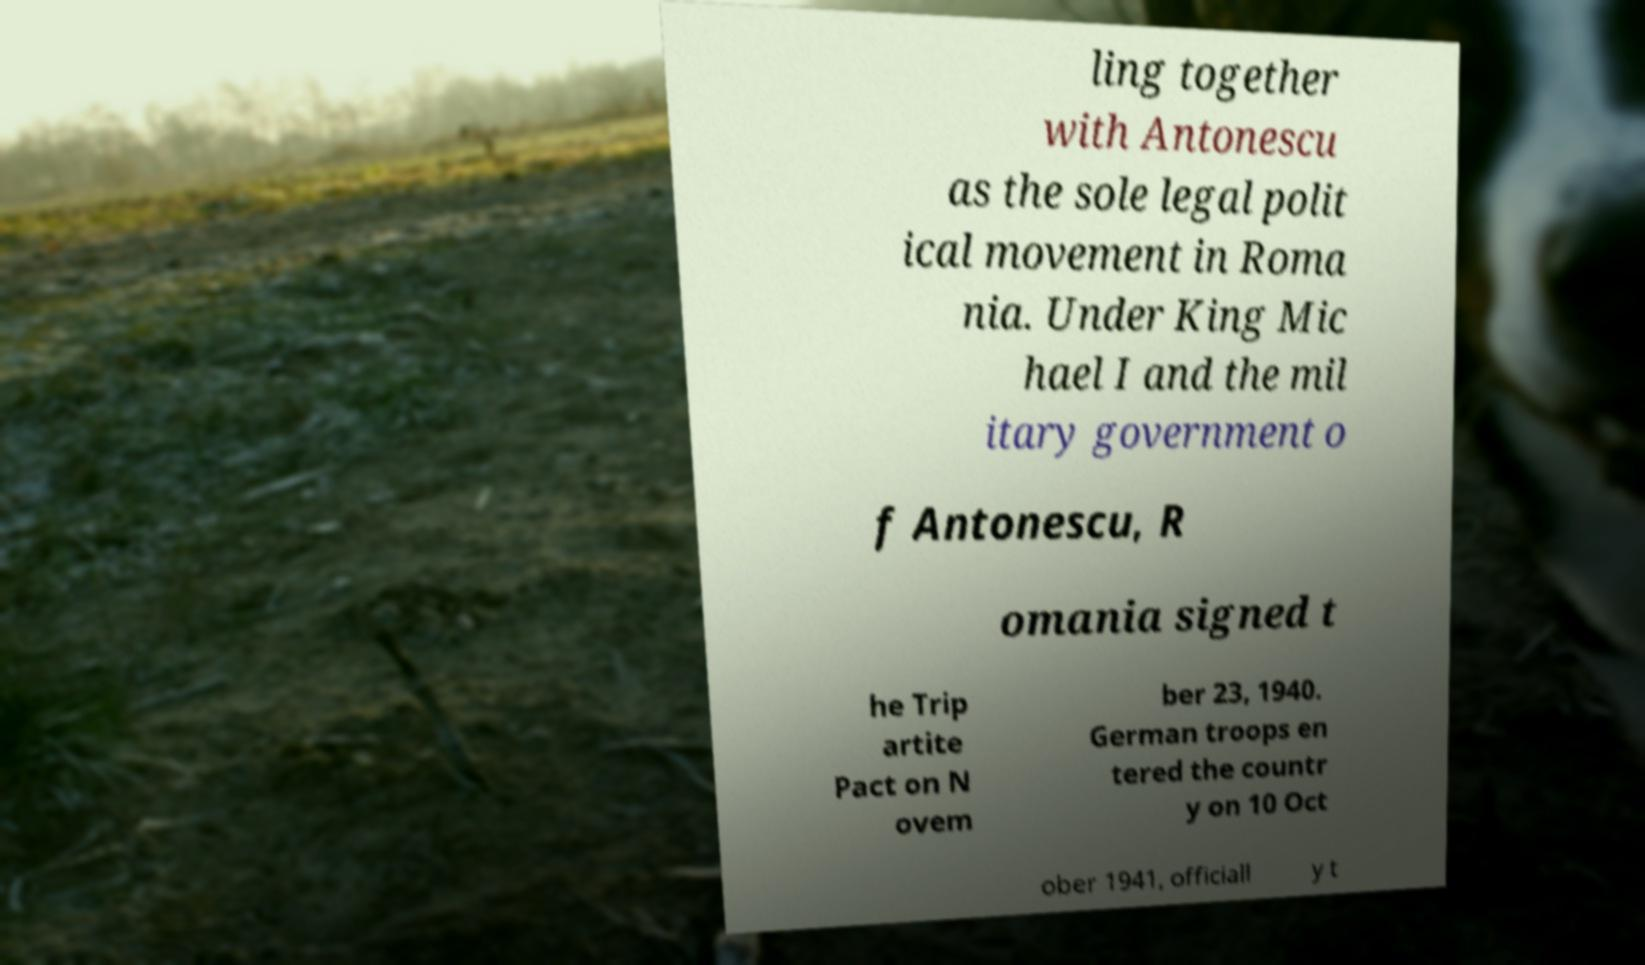I need the written content from this picture converted into text. Can you do that? ling together with Antonescu as the sole legal polit ical movement in Roma nia. Under King Mic hael I and the mil itary government o f Antonescu, R omania signed t he Trip artite Pact on N ovem ber 23, 1940. German troops en tered the countr y on 10 Oct ober 1941, officiall y t 